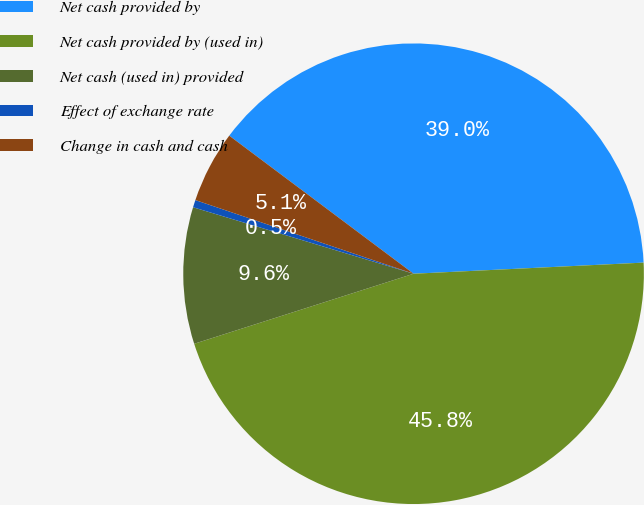<chart> <loc_0><loc_0><loc_500><loc_500><pie_chart><fcel>Net cash provided by<fcel>Net cash provided by (used in)<fcel>Net cash (used in) provided<fcel>Effect of exchange rate<fcel>Change in cash and cash<nl><fcel>39.0%<fcel>45.85%<fcel>9.58%<fcel>0.52%<fcel>5.05%<nl></chart> 